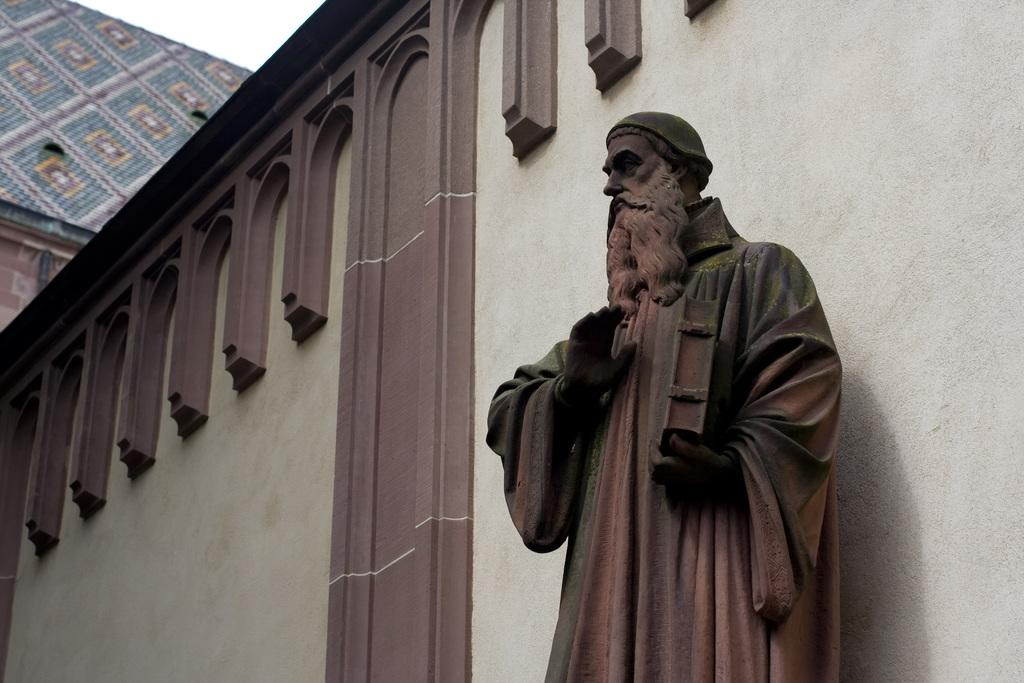What is the main subject in the image? There is a statue in the image. What is located behind the statue? There is a wall of a building behind the statue. What can be seen in the background of the image? The sky is visible in the background of the image. What type of chalk is being used to draw on the edge of the statue in the image? There is no chalk or drawing present on the statue in the image. 